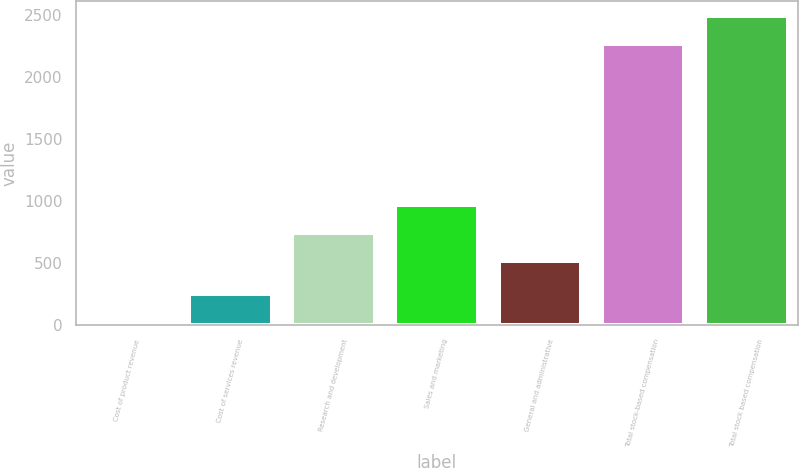<chart> <loc_0><loc_0><loc_500><loc_500><bar_chart><fcel>Cost of product revenue<fcel>Cost of services revenue<fcel>Research and development<fcel>Sales and marketing<fcel>General and administrative<fcel>Total stock-based compensation<fcel>Total stock based compensation<nl><fcel>26<fcel>249.8<fcel>743.8<fcel>967.6<fcel>520<fcel>2264<fcel>2487.8<nl></chart> 